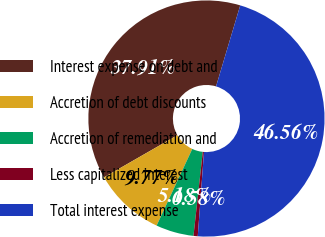<chart> <loc_0><loc_0><loc_500><loc_500><pie_chart><fcel>Interest expense on debt and<fcel>Accretion of debt discounts<fcel>Accretion of remediation and<fcel>Less capitalized interest<fcel>Total interest expense<nl><fcel>37.91%<fcel>9.77%<fcel>5.18%<fcel>0.58%<fcel>46.56%<nl></chart> 